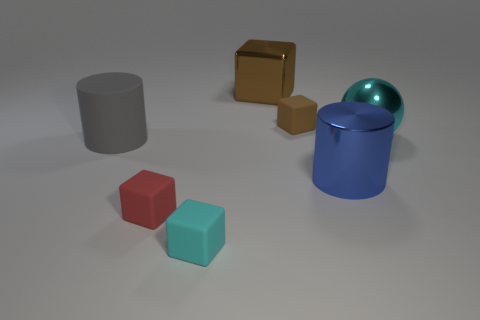Add 1 red objects. How many objects exist? 8 Subtract all balls. How many objects are left? 6 Subtract 1 blue cylinders. How many objects are left? 6 Subtract all small cubes. Subtract all big rubber cylinders. How many objects are left? 3 Add 1 cyan cubes. How many cyan cubes are left? 2 Add 5 cylinders. How many cylinders exist? 7 